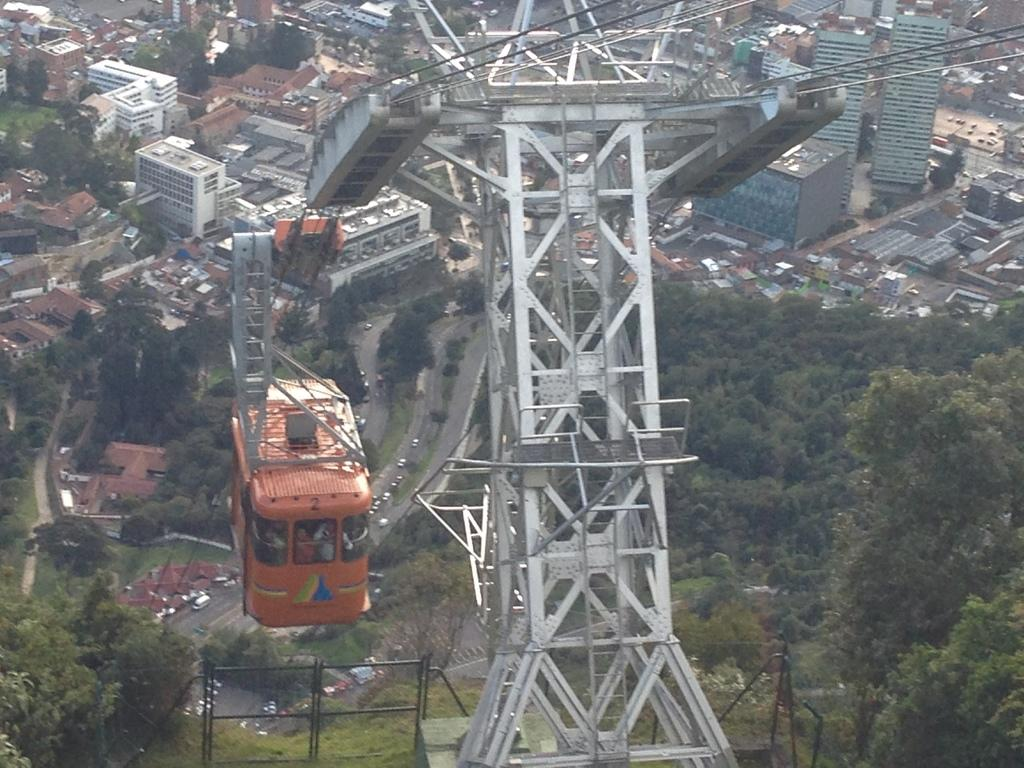What is located in the foreground of the image? There is a tower and a cable car in the foreground of the image. What can be seen in the background of the image? There are trees, buildings, and vehicles in the background of the image. What might be the purpose of the boundary at the bottom side of the image? The boundary at the bottom side of the image might be to frame the scene or to indicate the edge of the area being depicted. What type of sack is being used to carry the chalk in the image? There is no sack or chalk present in the image. What is the texture of the chin of the person in the image? There is no person present in the image, so it is not possible to determine the texture of their chin. 